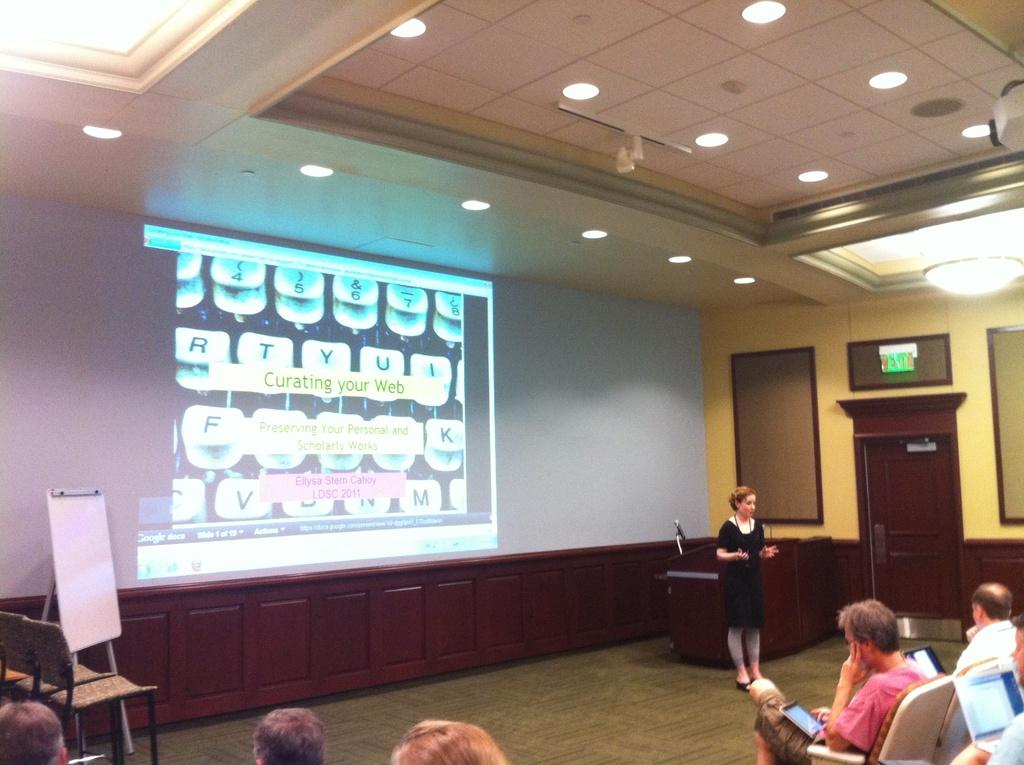<image>
Relay a brief, clear account of the picture shown. A woman is presenting as shown on the wall the subject of Curating your Web to an audience 